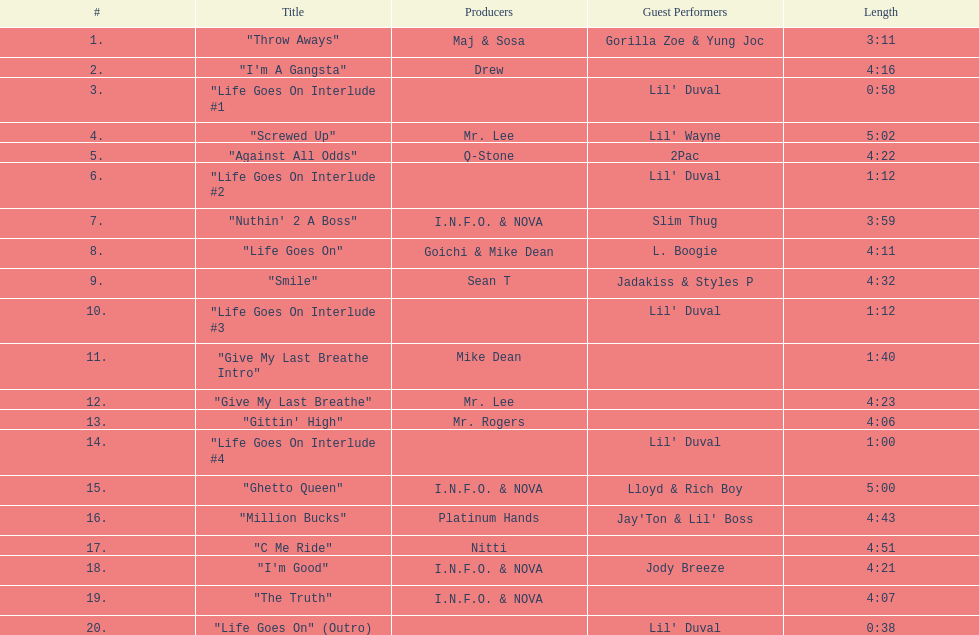What is the running time of the album's longest track? 5:02. 